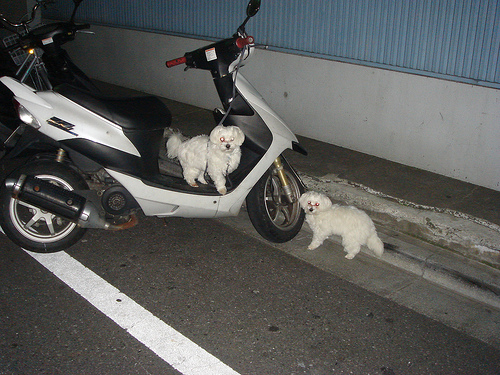Can you describe how the dog's presence alters the scene, considering its placement and expression? The dog sitting on the motorcycle instantly adds a touch of curiosity and playfulness to the scene. The dog's relaxed posture and indifferent expression suggest a sense of familiarity and comfort with the setting, highlighting an endearing juxtaposition of an ordinary vehicle with an unexpected, charming occupant. 